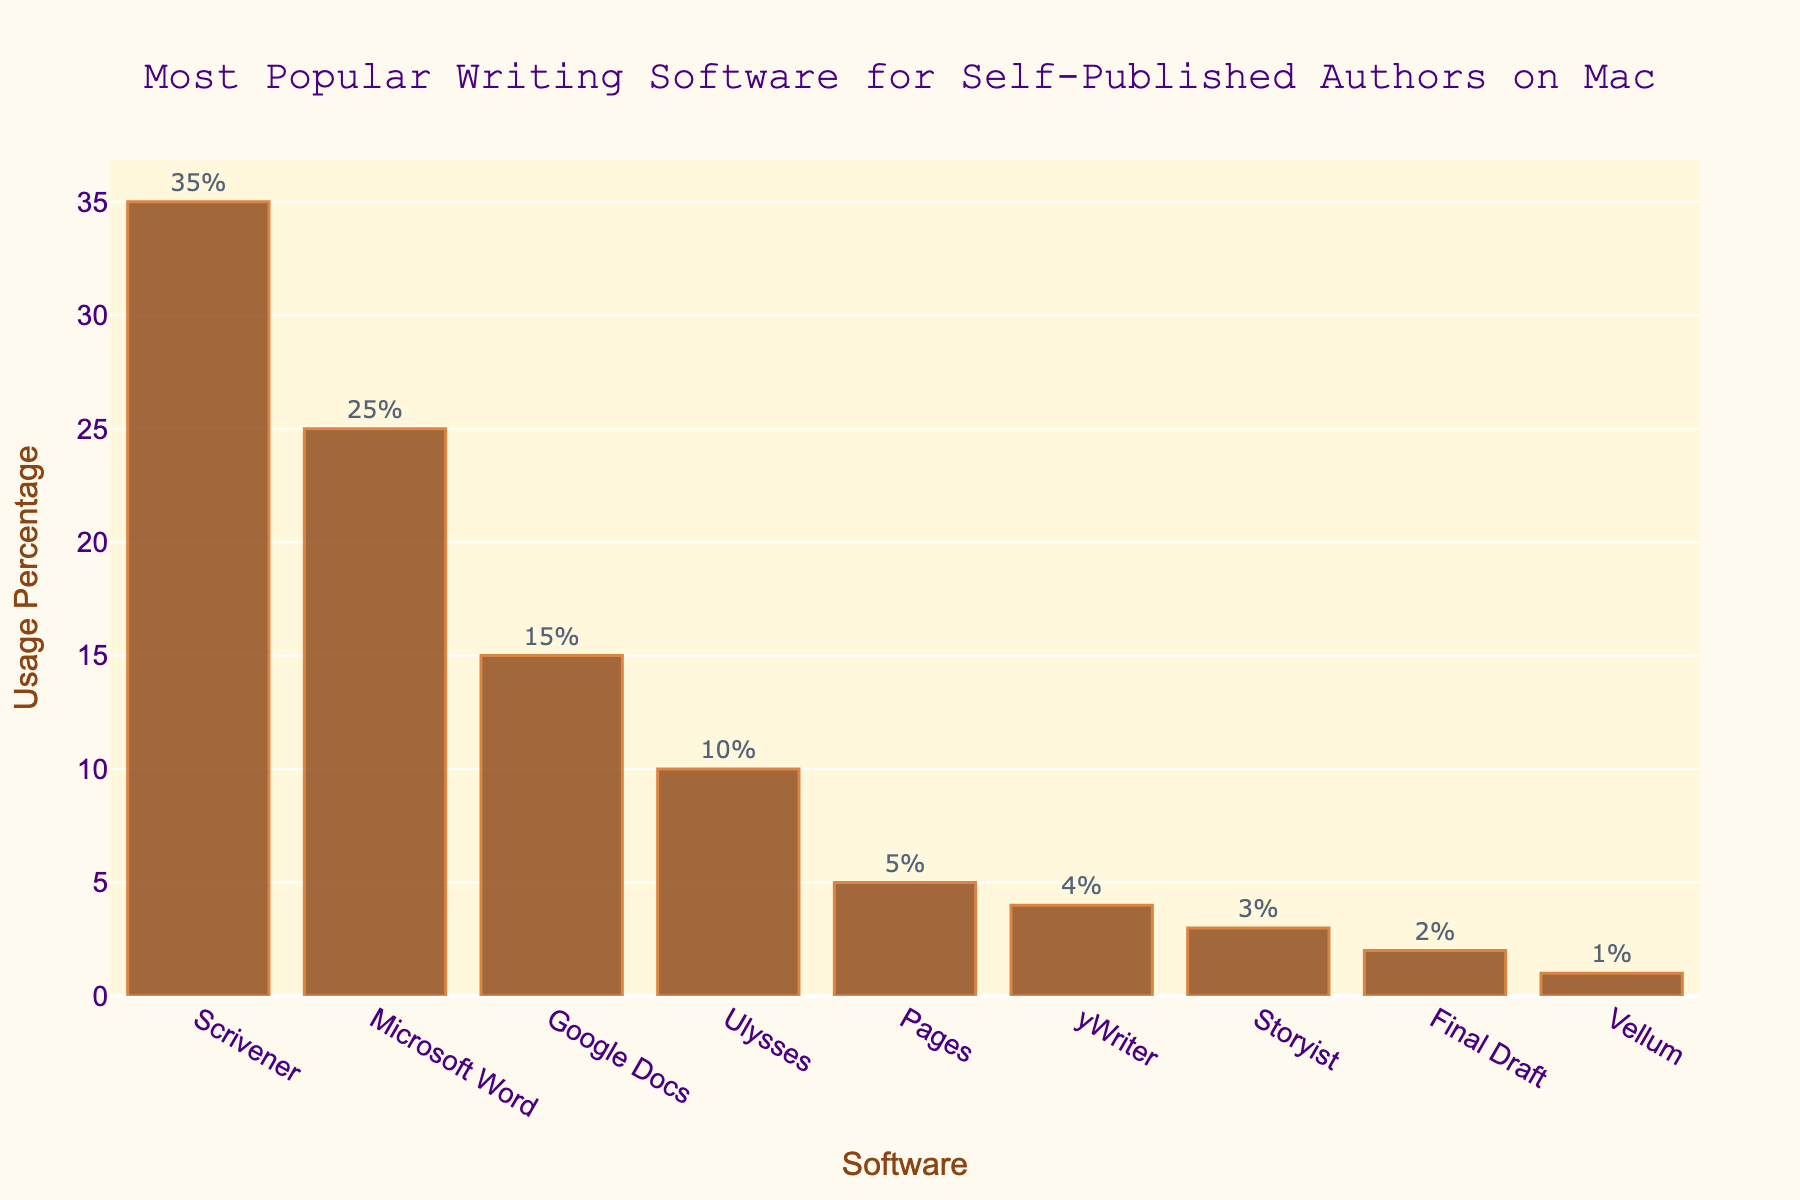What is the most popular writing software for self-published authors on Mac? The highest bar on the bar chart represents the most popular writing software. The bar for Scrivener is the tallest, indicating it has the highest usage percentage among all the listed software.
Answer: Scrivener How much more popular is Scrivener than Microsoft Word? To find how much more popular Scrivener is than Microsoft Word, subtract the usage percentage of Microsoft Word from that of Scrivener. Scrivener's usage percentage is 35%, and Microsoft Word's is 25%. 35% - 25% = 10%
Answer: 10% Which software has the lowest usage percentage? The shortest bar on the bar chart represents the software with the lowest usage percentage. Vellum has the shortest bar, indicating it has the lowest usage percentage.
Answer: Vellum What is the total usage percentage of Scrivener, Microsoft Word, and Google Docs combined? Add the usage percentages of Scrivener, Microsoft Word, and Google Docs together. Scrivener is 35%, Microsoft Word is 25%, and Google Docs is 15%. 35% + 25% + 15% = 75%
Answer: 75% Which writing software has a higher usage percentage: Pages or Ulysses? Compare the heights of the bars for Pages and Ulysses. Ulysses has a usage percentage of 10%, whereas Pages has a usage percentage of 5%.
Answer: Ulysses What is the difference in usage percentage between the software with the highest and lowest usage? Subtract the usage percentage of the software with the lowest usage (Vellum, 1%) from the software with the highest usage (Scrivener, 35%). 35% - 1% = 34%
Answer: 34% How many software options have a usage percentage of 5% or lower? Count the bars on the bar chart that have a height corresponding to 5% or lower. Pages (5%), yWriter (4%), Storyist (3%), Final Draft (2%), and Vellum (1%) each have a usage of 5% or lower.
Answer: 5 